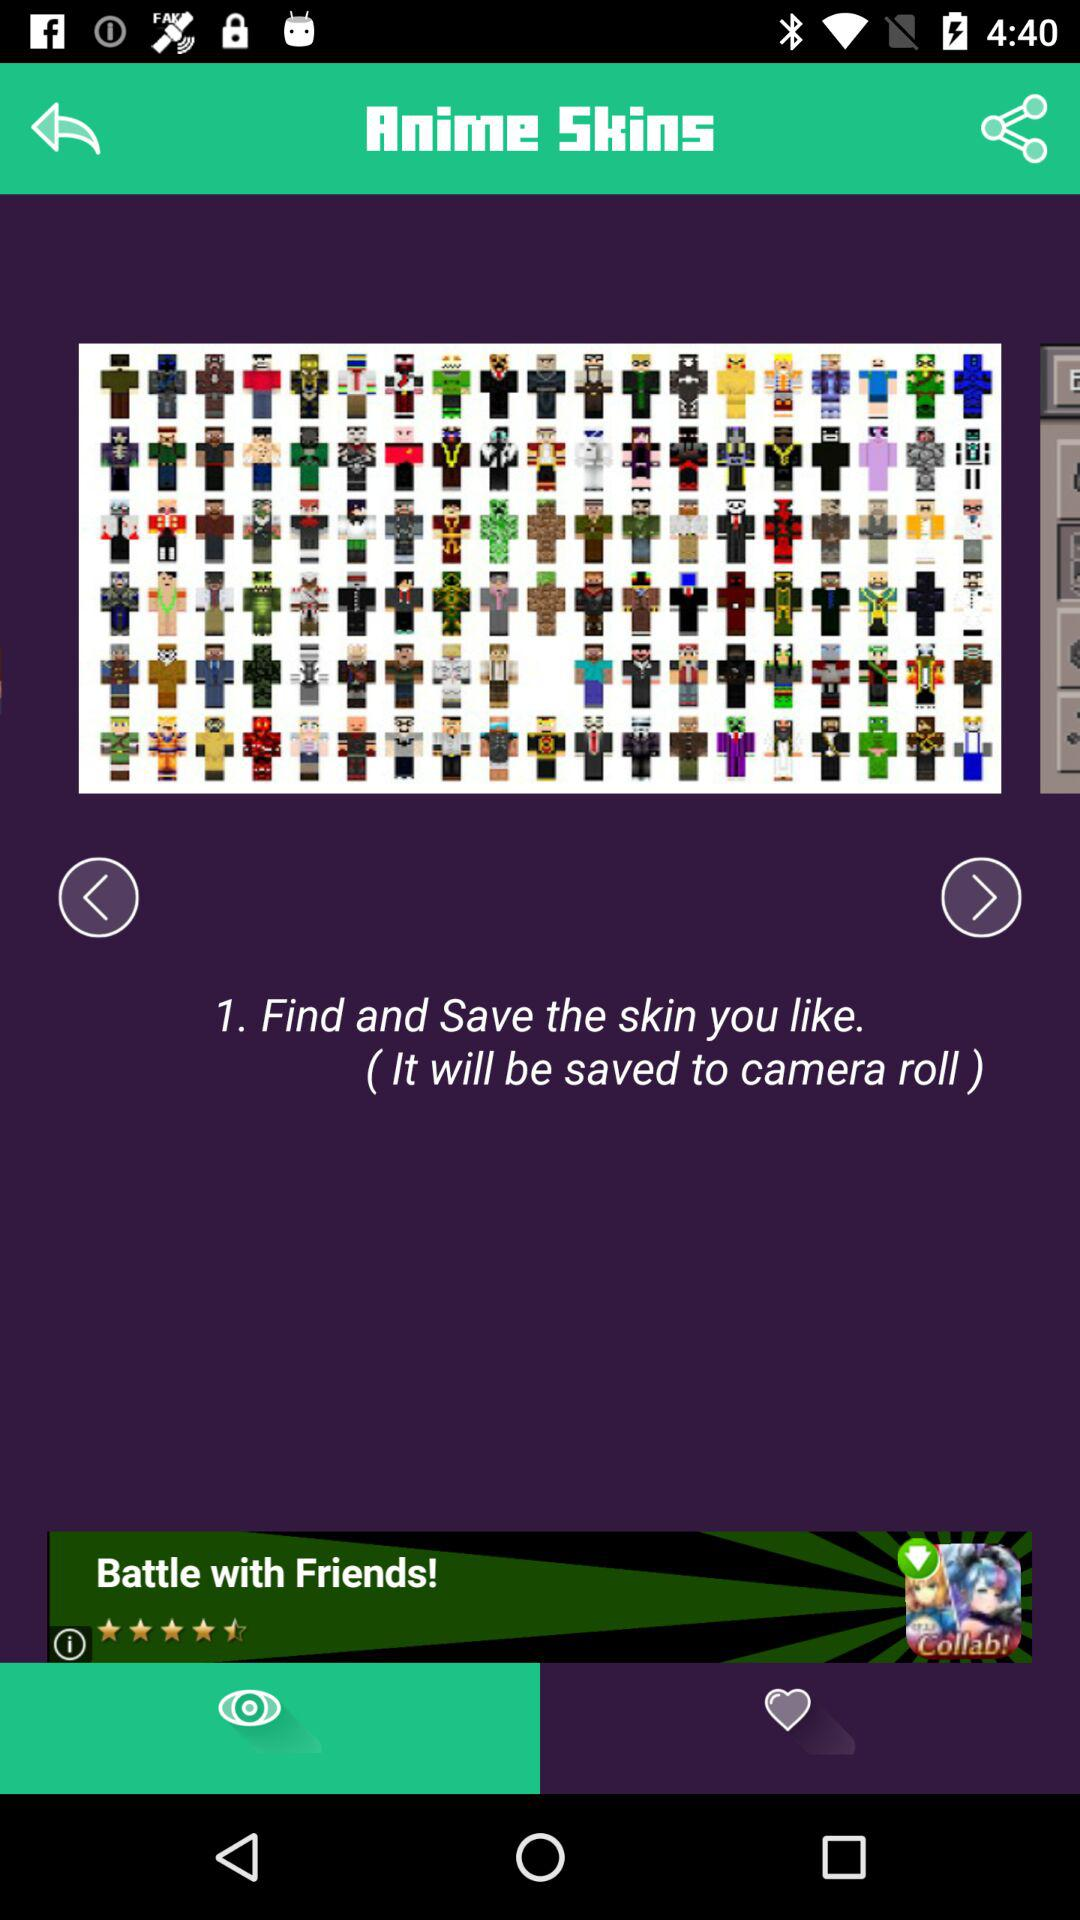What is the app name? The app name is "Anime Skins". 